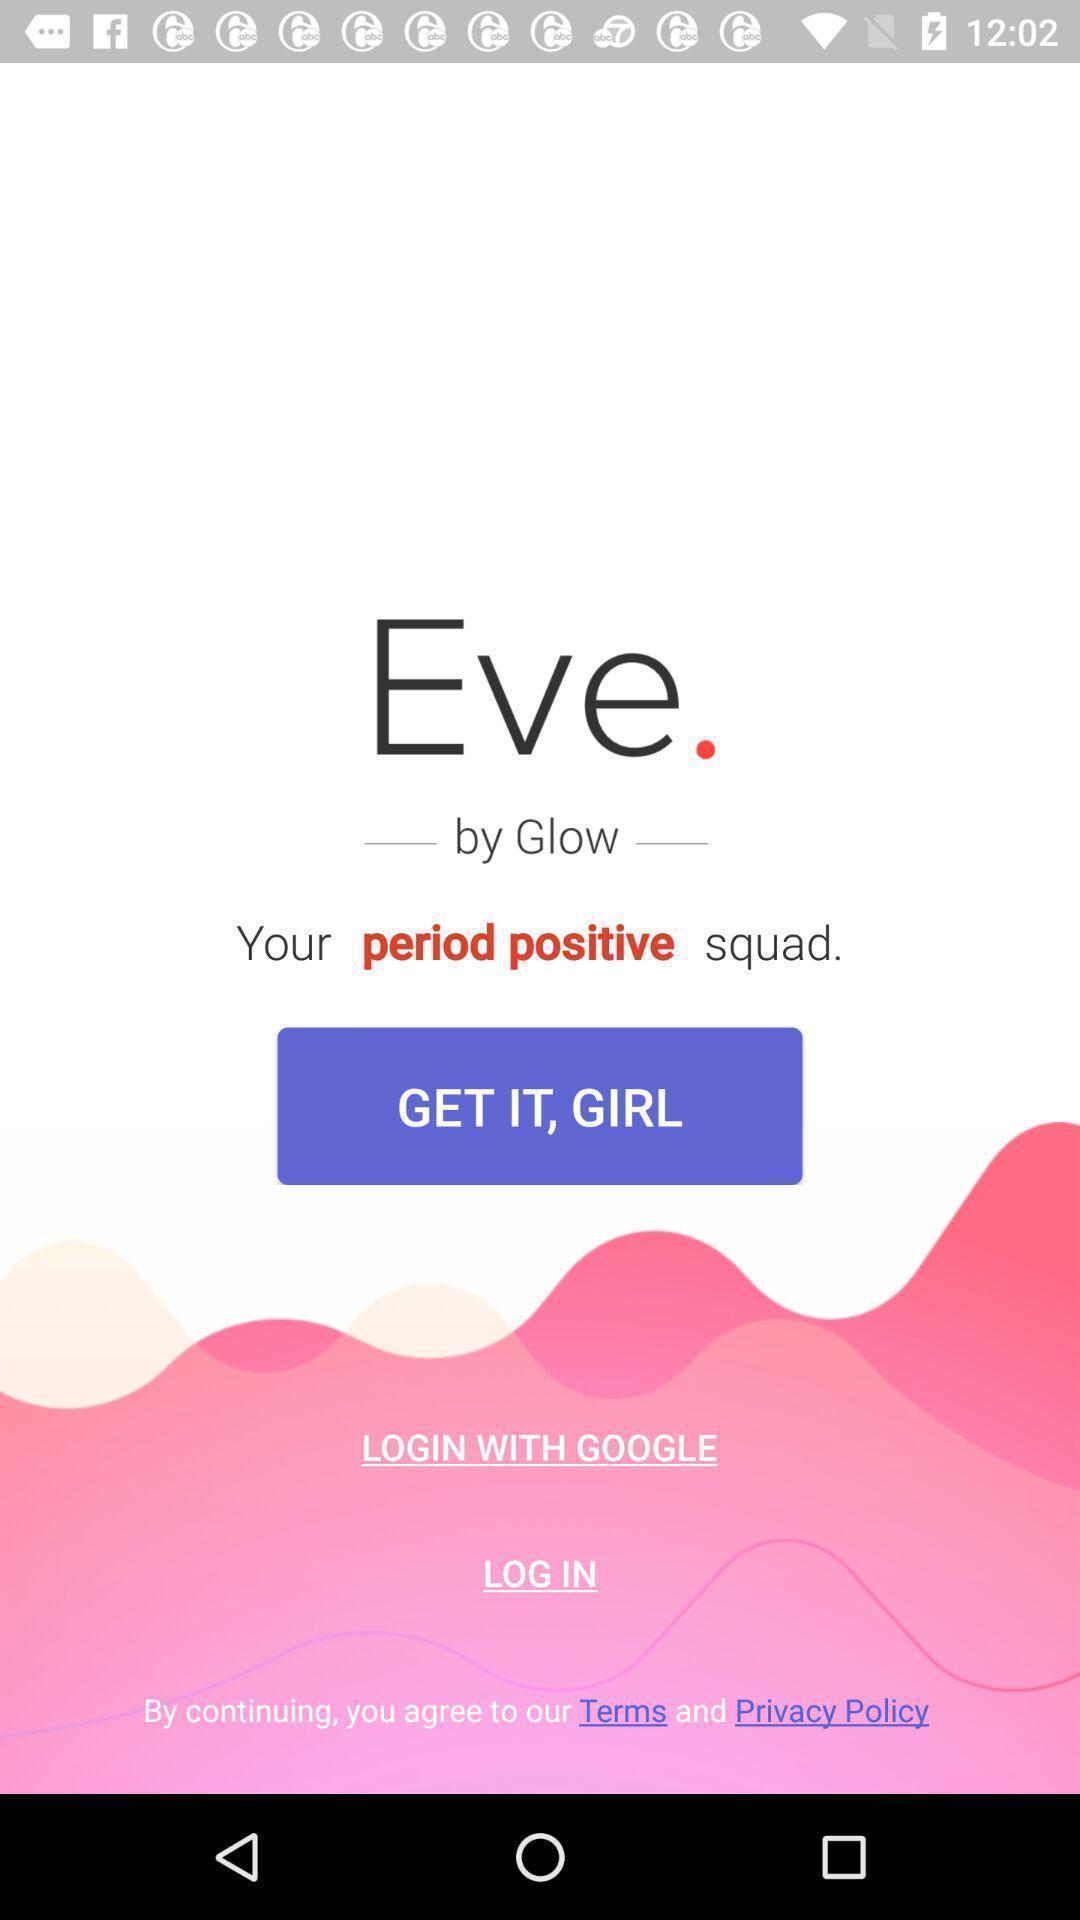What details can you identify in this image? Welcome page. 